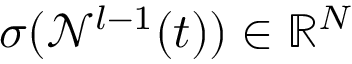<formula> <loc_0><loc_0><loc_500><loc_500>\sigma ( \mathcal { N } ^ { l - 1 } ( t ) ) \in \mathbb { R } ^ { N }</formula> 